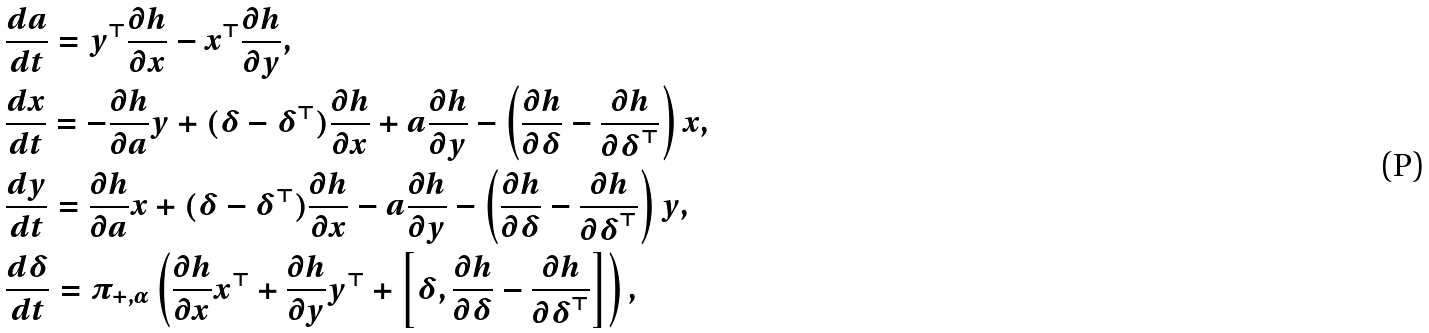<formula> <loc_0><loc_0><loc_500><loc_500>& \frac { d a } { d t } = y ^ { \top } \frac { \partial h } { \partial x } - x ^ { \top } \frac { \partial h } { \partial y } , \\ & \frac { d x } { d t } = - \frac { \partial h } { \partial a } y + ( { \boldsymbol \delta } - { \boldsymbol \delta } ^ { \top } ) \frac { \partial h } { \partial x } + a \frac { \partial h } { \partial y } - \left ( \frac { \partial h } { \partial { \boldsymbol \delta } } - \frac { \partial h } { \partial { \boldsymbol \delta } ^ { \top } } \right ) x , \\ & \frac { d y } { d t } = \frac { \partial h } { \partial a } x + ( { \boldsymbol \delta } - { \boldsymbol \delta } ^ { \top } ) \frac { \partial h } { \partial x } - a \frac { \partial h } { \partial y } - \left ( \frac { \partial h } { \partial { \boldsymbol \delta } } - \frac { \partial h } { \partial { \boldsymbol \delta } ^ { \top } } \right ) y , \\ & \frac { d { \boldsymbol \delta } } { d t } = \pi _ { + , \alpha } \left ( \frac { \partial h } { \partial x } x ^ { \top } + \frac { \partial h } { \partial y } y ^ { \top } + \left [ { \boldsymbol \delta } , \frac { \partial h } { \partial { \boldsymbol \delta } } - \frac { \partial h } { \partial { \boldsymbol \delta } ^ { \top } } \right ] \right ) ,</formula> 